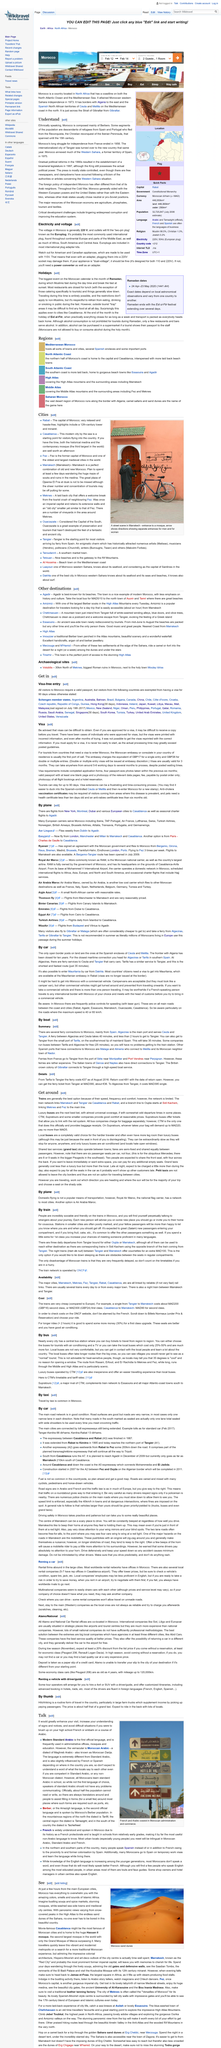Identify some key points in this picture. The picture depicts a sand dune. Moroccan Arabic is influenced by French and Spanish to a slight extent. The Western Sahara was formerly a territory of Spain. Royal Air Maroc is the national flag carrier of Morocco. The two modes of transport discussed for travelling in Morocco are planes and trains. 